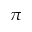<formula> <loc_0><loc_0><loc_500><loc_500>\pi</formula> 